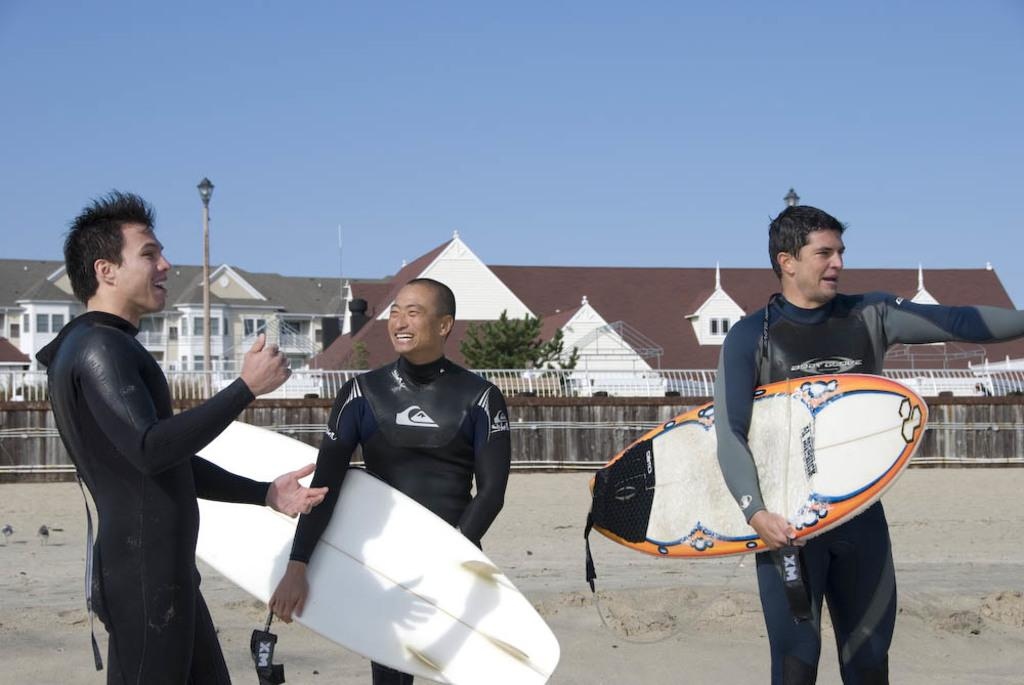How many people are in the image? There are three persons standing in the middle of the image. What objects are associated with the people in the image? There are surfboards in the image. What can be seen in the background of the image? There is a tree and a house in the background of the image. What is visible at the top of the image? The sky is visible in the image. What type of guitar can be seen being played by one of the persons in the image? There is no guitar present in the image; the people are not holding or playing any musical instruments. 